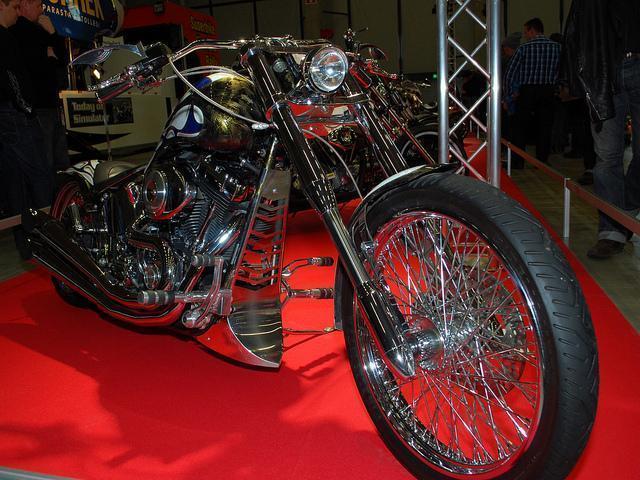Where is this bike located?
Answer the question by selecting the correct answer among the 4 following choices.
Options: Driveway, mechanic, museum, parking lot. Museum. 